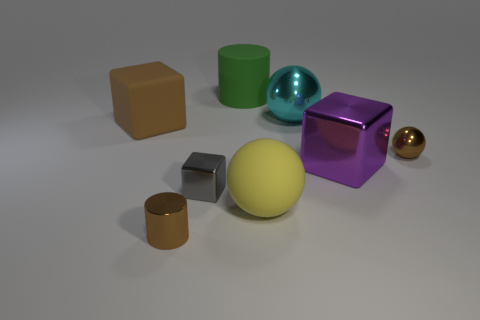Does the big matte cube have the same color as the small metal cylinder?
Keep it short and to the point. Yes. What is the color of the large cube to the left of the cylinder that is in front of the brown thing that is behind the small brown sphere?
Provide a short and direct response. Brown. Is there a brown metal object that has the same shape as the tiny gray metallic object?
Give a very brief answer. No. Are there more large cyan balls that are right of the tiny shiny block than large brown metallic spheres?
Give a very brief answer. Yes. What number of metal objects are yellow blocks or balls?
Offer a very short reply. 2. There is a brown object that is to the left of the tiny gray metallic thing and in front of the brown rubber thing; how big is it?
Offer a terse response. Small. Is there a large yellow rubber thing that is behind the brown thing on the right side of the large rubber sphere?
Your response must be concise. No. How many rubber cubes are behind the large green object?
Your answer should be compact. 0. What is the color of the other metallic thing that is the same shape as the gray thing?
Provide a short and direct response. Purple. Is the large object that is left of the big cylinder made of the same material as the large cyan ball that is behind the big purple cube?
Your response must be concise. No. 